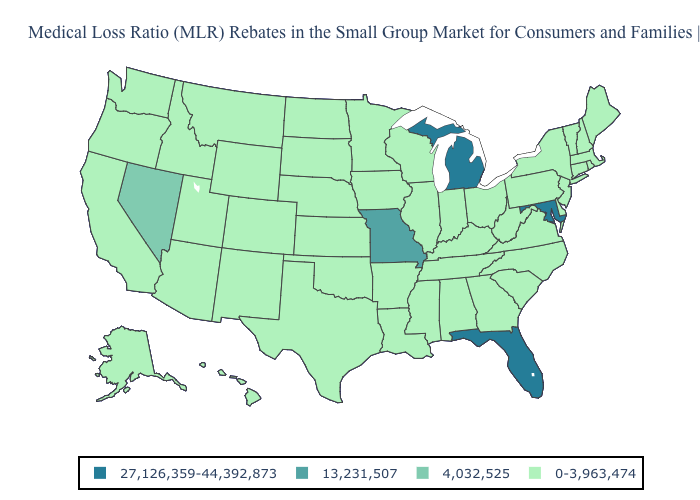Does the map have missing data?
Short answer required. No. Among the states that border Nevada , which have the lowest value?
Be succinct. Arizona, California, Idaho, Oregon, Utah. What is the value of Indiana?
Short answer required. 0-3,963,474. Name the states that have a value in the range 13,231,507?
Short answer required. Missouri. Does Iowa have the same value as Florida?
Answer briefly. No. Which states have the highest value in the USA?
Keep it brief. Florida, Maryland, Michigan. What is the highest value in states that border Kansas?
Write a very short answer. 13,231,507. Does Mississippi have the highest value in the South?
Give a very brief answer. No. What is the highest value in the West ?
Keep it brief. 4,032,525. What is the value of Oklahoma?
Be succinct. 0-3,963,474. Does Arizona have the lowest value in the West?
Give a very brief answer. Yes. Does Hawaii have a lower value than Tennessee?
Answer briefly. No. 